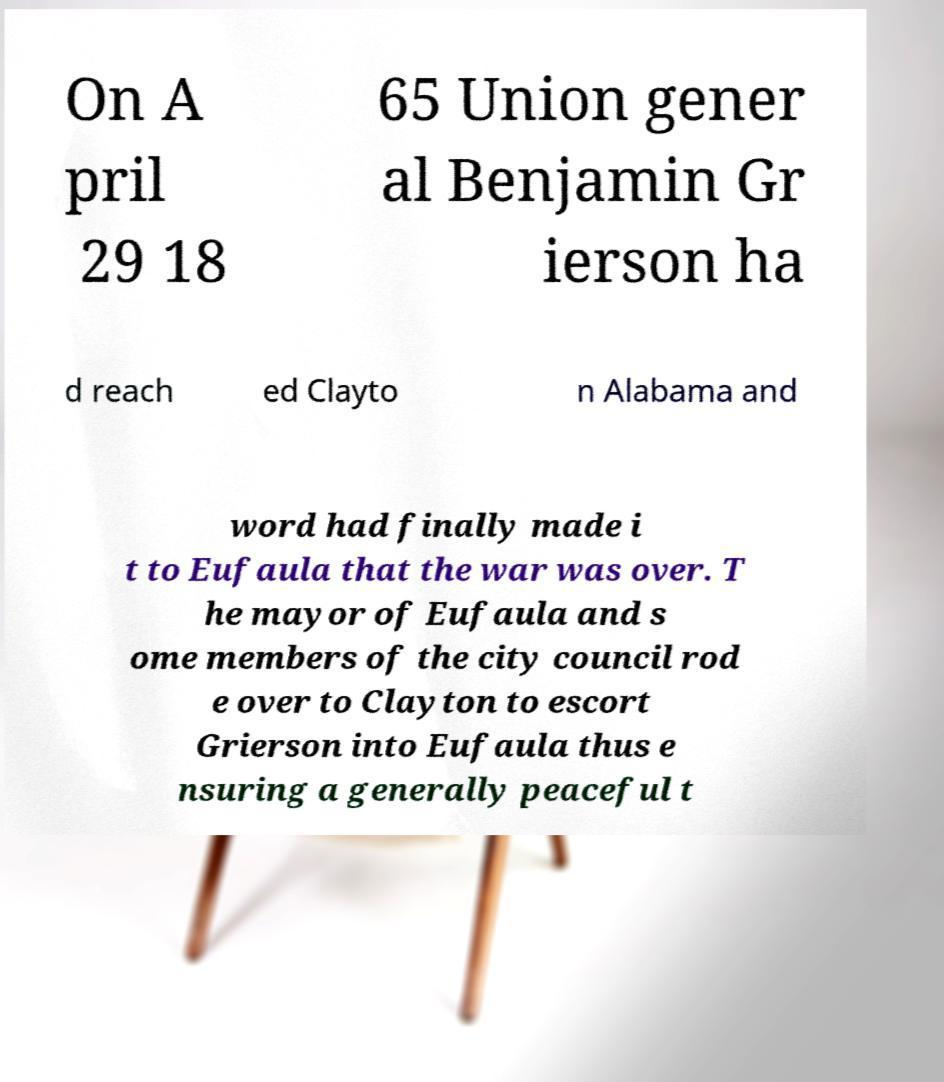Can you read and provide the text displayed in the image?This photo seems to have some interesting text. Can you extract and type it out for me? On A pril 29 18 65 Union gener al Benjamin Gr ierson ha d reach ed Clayto n Alabama and word had finally made i t to Eufaula that the war was over. T he mayor of Eufaula and s ome members of the city council rod e over to Clayton to escort Grierson into Eufaula thus e nsuring a generally peaceful t 